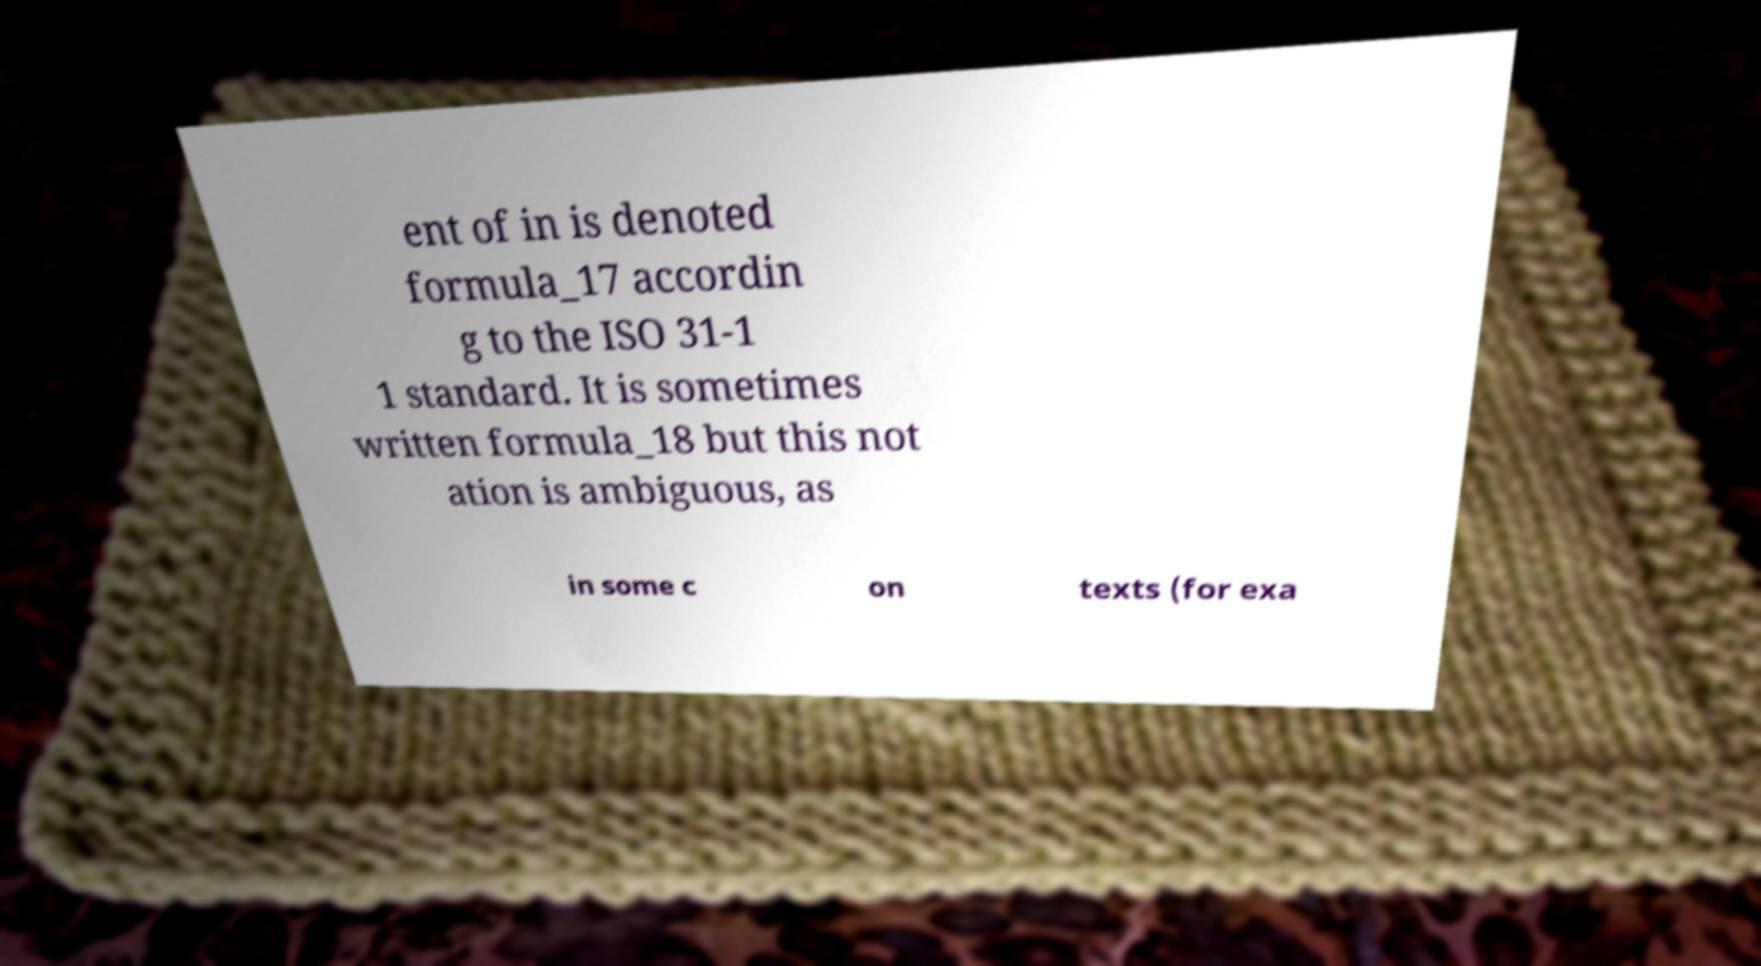What messages or text are displayed in this image? I need them in a readable, typed format. ent of in is denoted formula_17 accordin g to the ISO 31-1 1 standard. It is sometimes written formula_18 but this not ation is ambiguous, as in some c on texts (for exa 